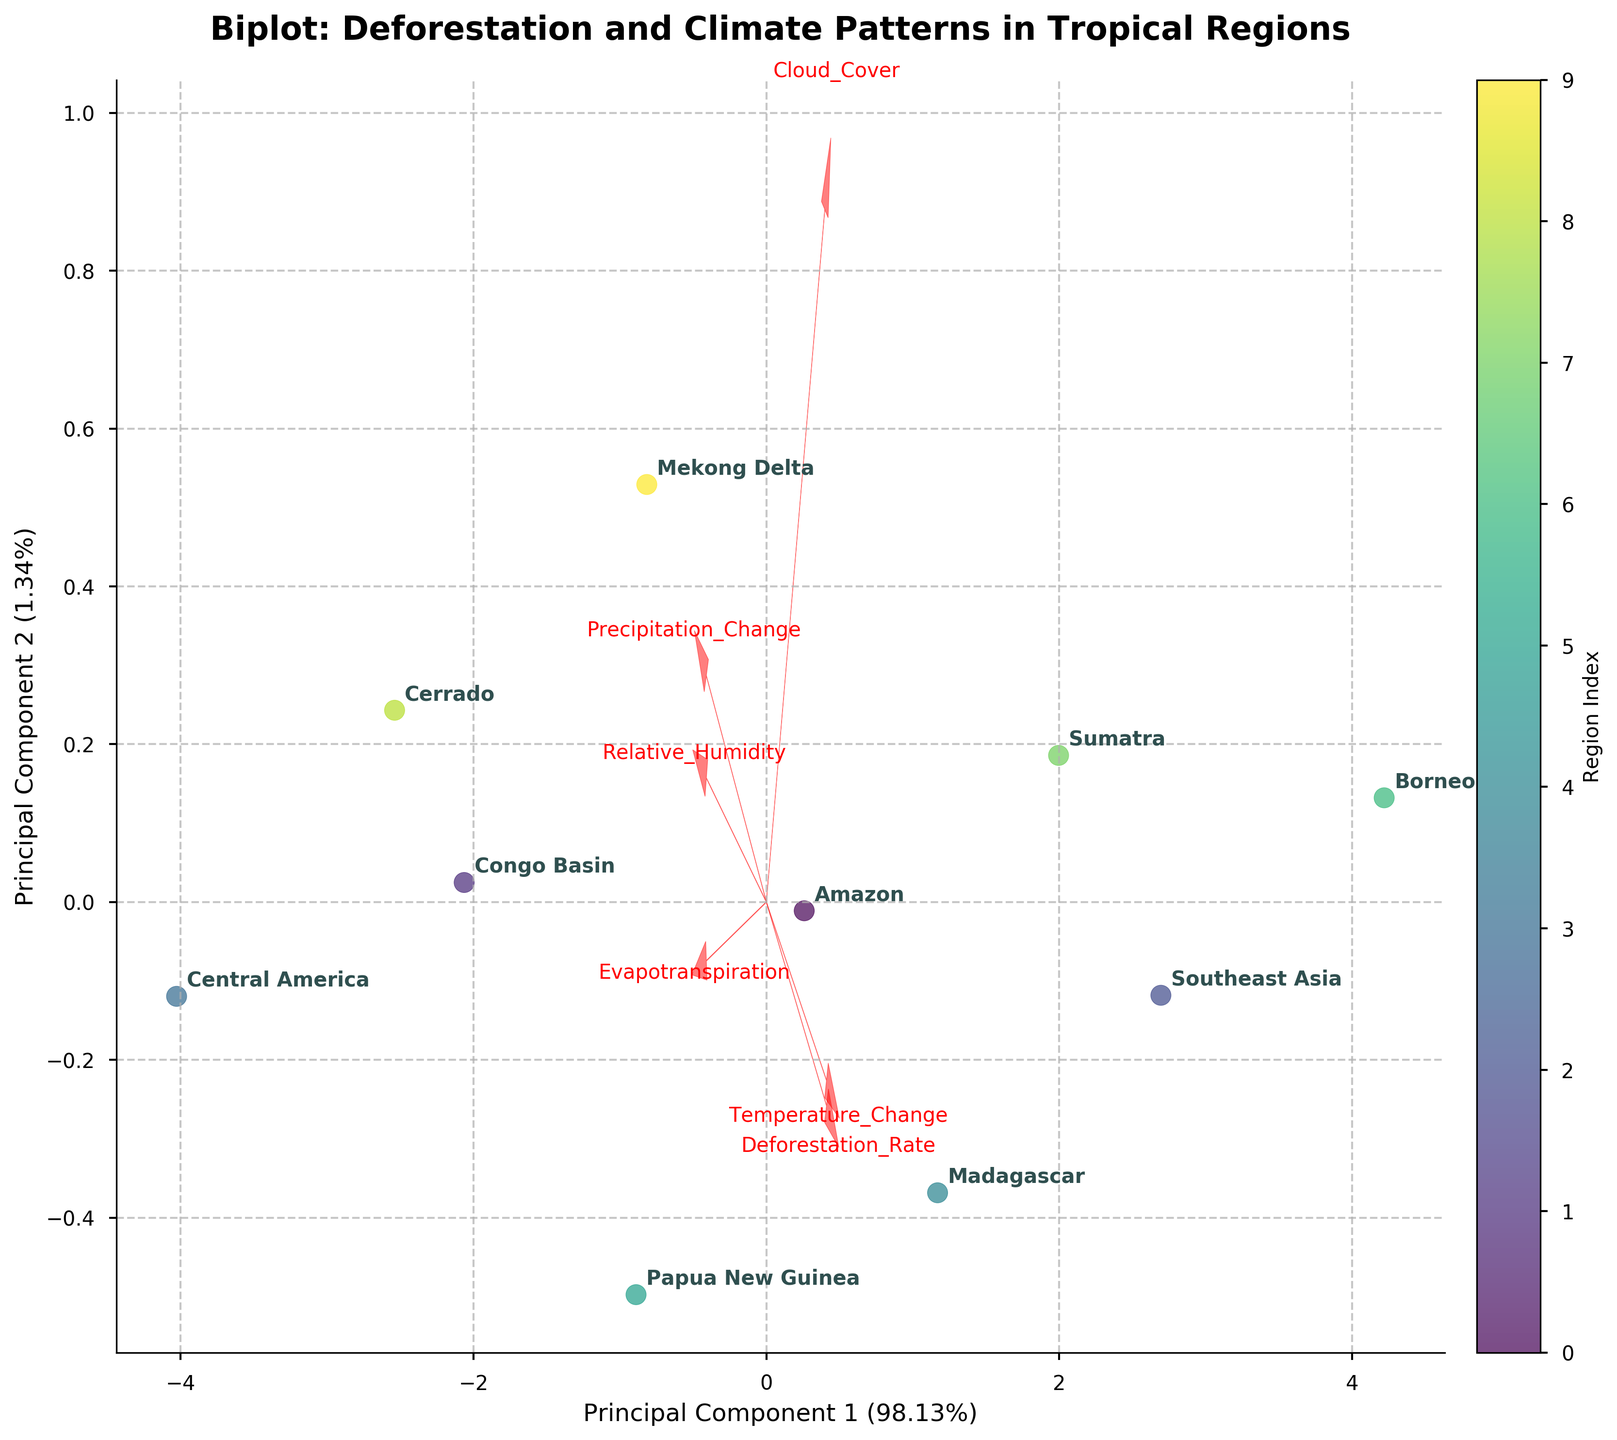How many regions are represented in the biplot? Count the different region names annotated in the plot. There are 10 distinct regions: Amazon, Congo Basin, Southeast Asia, Central America, Madagascar, Papua New Guinea, Borneo, Sumatra, Cerrado, and Mekong Delta.
Answer: 10 What is the title of the biplot? It's displayed at the top of the plot in a bold and large font. The title is "Biplot: Deforestation and Climate Patterns in Tropical Regions".
Answer: Biplot: Deforestation and Climate Patterns in Tropical Regions Which principal component explains the most variance in the data? Look at the axis labels for Principal Component 1 and Principal Component 2, which display the explained variance. Principal Component 1 has a larger explained variance percentage.
Answer: Principal Component 1 Which region has the highest deforestation rate? By finding the region closest to the vector labeled "Deforestation_Rate", we can determine that Borneo is closest.
Answer: Borneo Which variable is positively related to both Principal Component 1 and Principal Component 2? Look at the feature vectors. The feature vector that points in the positive direction of both axes represents the variable we seek. "Cloud_Cover" points in the positive directions of both Principal Component 1 and 2.
Answer: Cloud_Cover Are "Temperature Change" and "Precipitation Change" positively correlated? Check if the feature vectors for these two variables point in the same direction. The vectors for "Temperature_Change" and "Precipitation_Change" point in nearly opposite directions, indicating a negative correlation.
Answer: No Which region is most closely associated with the highest precipitation change? Locate the region closest to the vector labeled "Precipitation_Change". Borneo is closest to this vector.
Answer: Borneo Compare the deforestation rates of Central America and Southeast Asia. Which is higher? Find the relative positions of the two regions to the "Deforestation_Rate" vector. Southeast Asia is closer to the higher end of the deforestation rate vector compared to Central America.
Answer: Southeast Asia How does the variable "Relative Humidity" contribute to the first principal component? Examine the direction and length of the feature vector for "Relative_Humidity" relative to Principal Component 1. The vector contributes modestly in a positive direction.
Answer: Modest positive contribution Which variable has the largest magnitude vector length, indicating the strongest influence on the components? Look for the feature vector with the longest length. The "Precipitation_Change" vector appears the longest.
Answer: Precipitation_Change 